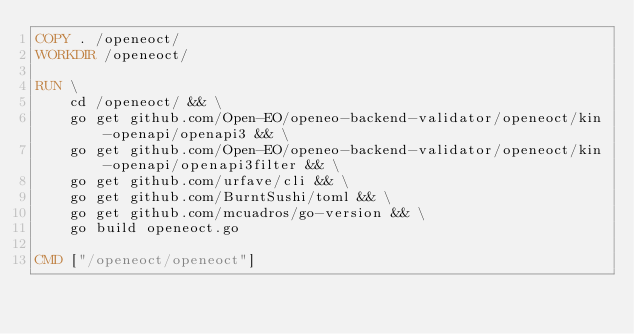Convert code to text. <code><loc_0><loc_0><loc_500><loc_500><_Dockerfile_>COPY . /openeoct/
WORKDIR /openeoct/

RUN \
    cd /openeoct/ && \
    go get github.com/Open-EO/openeo-backend-validator/openeoct/kin-openapi/openapi3 && \
    go get github.com/Open-EO/openeo-backend-validator/openeoct/kin-openapi/openapi3filter && \
    go get github.com/urfave/cli && \
    go get github.com/BurntSushi/toml && \
    go get github.com/mcuadros/go-version && \
    go build openeoct.go

CMD ["/openeoct/openeoct"]
</code> 